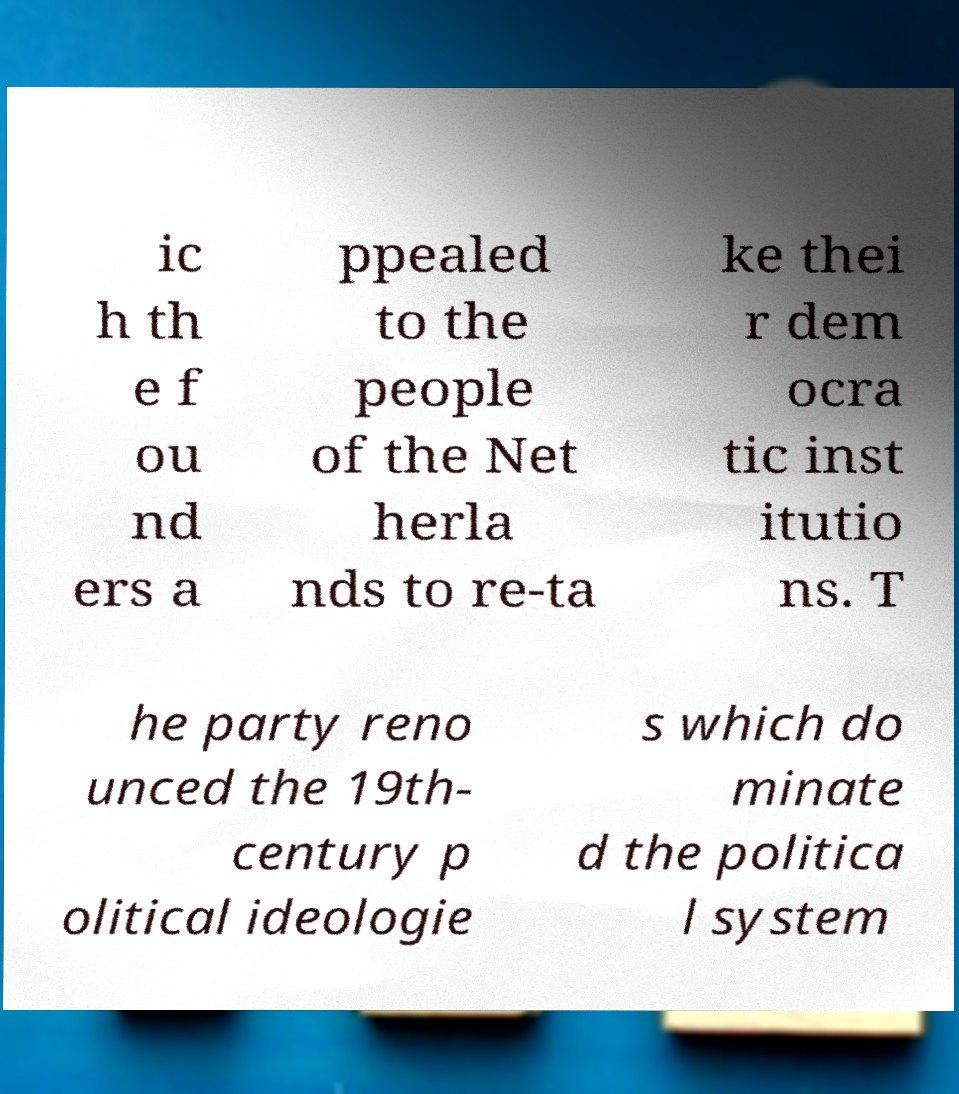For documentation purposes, I need the text within this image transcribed. Could you provide that? ic h th e f ou nd ers a ppealed to the people of the Net herla nds to re-ta ke thei r dem ocra tic inst itutio ns. T he party reno unced the 19th- century p olitical ideologie s which do minate d the politica l system 